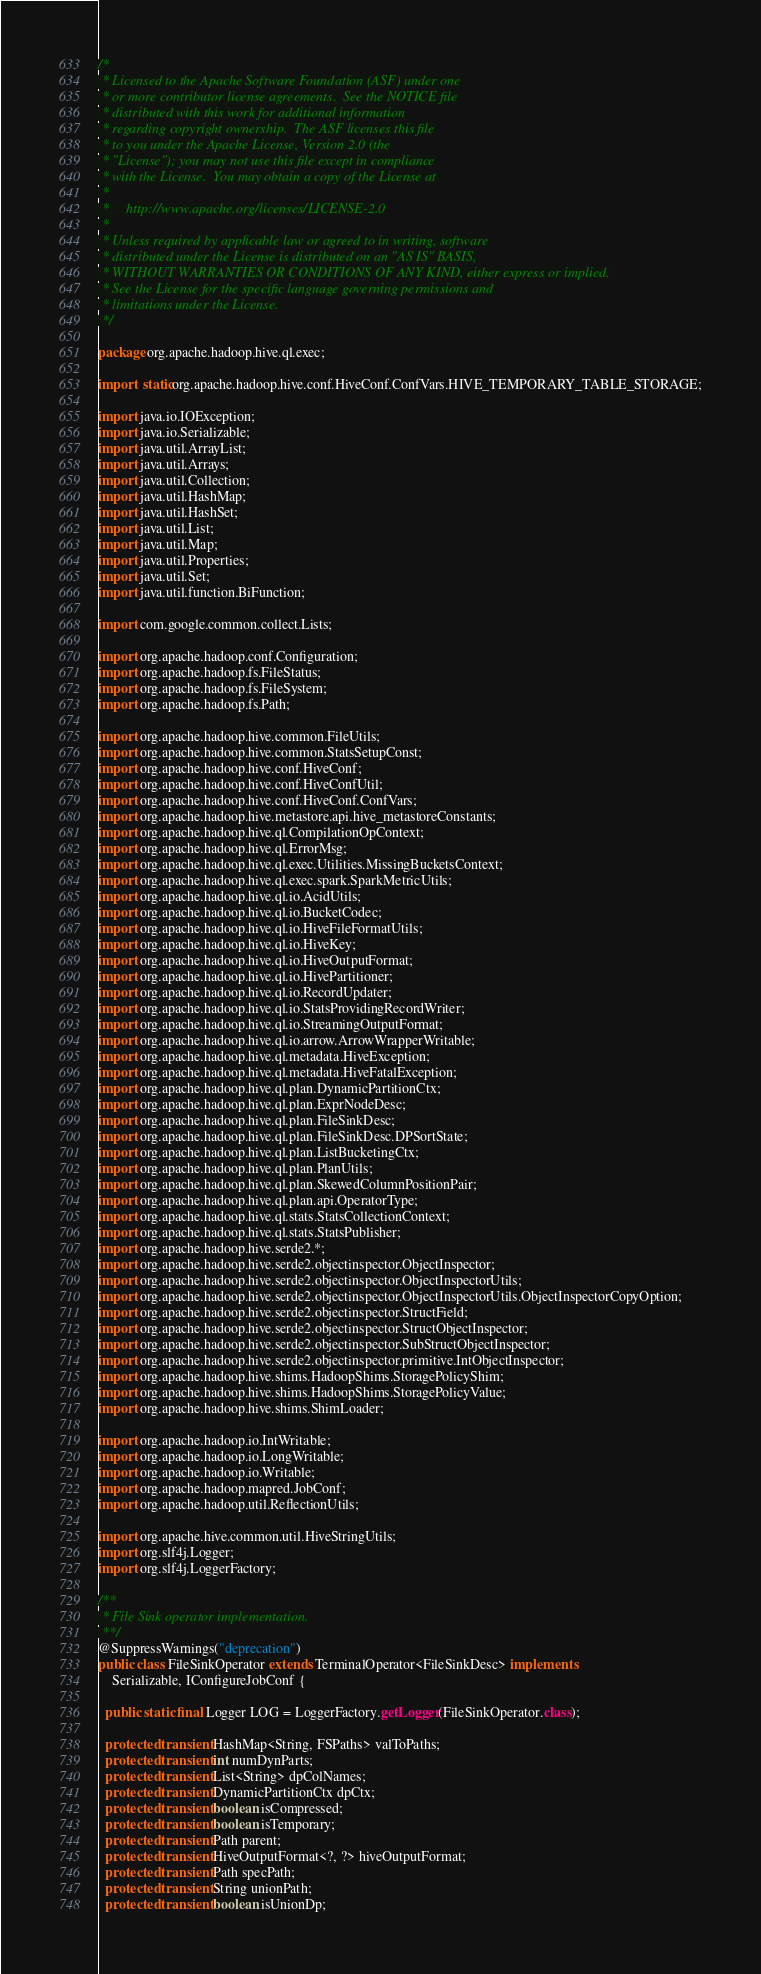Convert code to text. <code><loc_0><loc_0><loc_500><loc_500><_Java_>/*
 * Licensed to the Apache Software Foundation (ASF) under one
 * or more contributor license agreements.  See the NOTICE file
 * distributed with this work for additional information
 * regarding copyright ownership.  The ASF licenses this file
 * to you under the Apache License, Version 2.0 (the
 * "License"); you may not use this file except in compliance
 * with the License.  You may obtain a copy of the License at
 *
 *     http://www.apache.org/licenses/LICENSE-2.0
 *
 * Unless required by applicable law or agreed to in writing, software
 * distributed under the License is distributed on an "AS IS" BASIS,
 * WITHOUT WARRANTIES OR CONDITIONS OF ANY KIND, either express or implied.
 * See the License for the specific language governing permissions and
 * limitations under the License.
 */

package org.apache.hadoop.hive.ql.exec;

import static org.apache.hadoop.hive.conf.HiveConf.ConfVars.HIVE_TEMPORARY_TABLE_STORAGE;

import java.io.IOException;
import java.io.Serializable;
import java.util.ArrayList;
import java.util.Arrays;
import java.util.Collection;
import java.util.HashMap;
import java.util.HashSet;
import java.util.List;
import java.util.Map;
import java.util.Properties;
import java.util.Set;
import java.util.function.BiFunction;

import com.google.common.collect.Lists;

import org.apache.hadoop.conf.Configuration;
import org.apache.hadoop.fs.FileStatus;
import org.apache.hadoop.fs.FileSystem;
import org.apache.hadoop.fs.Path;

import org.apache.hadoop.hive.common.FileUtils;
import org.apache.hadoop.hive.common.StatsSetupConst;
import org.apache.hadoop.hive.conf.HiveConf;
import org.apache.hadoop.hive.conf.HiveConfUtil;
import org.apache.hadoop.hive.conf.HiveConf.ConfVars;
import org.apache.hadoop.hive.metastore.api.hive_metastoreConstants;
import org.apache.hadoop.hive.ql.CompilationOpContext;
import org.apache.hadoop.hive.ql.ErrorMsg;
import org.apache.hadoop.hive.ql.exec.Utilities.MissingBucketsContext;
import org.apache.hadoop.hive.ql.exec.spark.SparkMetricUtils;
import org.apache.hadoop.hive.ql.io.AcidUtils;
import org.apache.hadoop.hive.ql.io.BucketCodec;
import org.apache.hadoop.hive.ql.io.HiveFileFormatUtils;
import org.apache.hadoop.hive.ql.io.HiveKey;
import org.apache.hadoop.hive.ql.io.HiveOutputFormat;
import org.apache.hadoop.hive.ql.io.HivePartitioner;
import org.apache.hadoop.hive.ql.io.RecordUpdater;
import org.apache.hadoop.hive.ql.io.StatsProvidingRecordWriter;
import org.apache.hadoop.hive.ql.io.StreamingOutputFormat;
import org.apache.hadoop.hive.ql.io.arrow.ArrowWrapperWritable;
import org.apache.hadoop.hive.ql.metadata.HiveException;
import org.apache.hadoop.hive.ql.metadata.HiveFatalException;
import org.apache.hadoop.hive.ql.plan.DynamicPartitionCtx;
import org.apache.hadoop.hive.ql.plan.ExprNodeDesc;
import org.apache.hadoop.hive.ql.plan.FileSinkDesc;
import org.apache.hadoop.hive.ql.plan.FileSinkDesc.DPSortState;
import org.apache.hadoop.hive.ql.plan.ListBucketingCtx;
import org.apache.hadoop.hive.ql.plan.PlanUtils;
import org.apache.hadoop.hive.ql.plan.SkewedColumnPositionPair;
import org.apache.hadoop.hive.ql.plan.api.OperatorType;
import org.apache.hadoop.hive.ql.stats.StatsCollectionContext;
import org.apache.hadoop.hive.ql.stats.StatsPublisher;
import org.apache.hadoop.hive.serde2.*;
import org.apache.hadoop.hive.serde2.objectinspector.ObjectInspector;
import org.apache.hadoop.hive.serde2.objectinspector.ObjectInspectorUtils;
import org.apache.hadoop.hive.serde2.objectinspector.ObjectInspectorUtils.ObjectInspectorCopyOption;
import org.apache.hadoop.hive.serde2.objectinspector.StructField;
import org.apache.hadoop.hive.serde2.objectinspector.StructObjectInspector;
import org.apache.hadoop.hive.serde2.objectinspector.SubStructObjectInspector;
import org.apache.hadoop.hive.serde2.objectinspector.primitive.IntObjectInspector;
import org.apache.hadoop.hive.shims.HadoopShims.StoragePolicyShim;
import org.apache.hadoop.hive.shims.HadoopShims.StoragePolicyValue;
import org.apache.hadoop.hive.shims.ShimLoader;

import org.apache.hadoop.io.IntWritable;
import org.apache.hadoop.io.LongWritable;
import org.apache.hadoop.io.Writable;
import org.apache.hadoop.mapred.JobConf;
import org.apache.hadoop.util.ReflectionUtils;

import org.apache.hive.common.util.HiveStringUtils;
import org.slf4j.Logger;
import org.slf4j.LoggerFactory;

/**
 * File Sink operator implementation.
 **/
@SuppressWarnings("deprecation")
public class FileSinkOperator extends TerminalOperator<FileSinkDesc> implements
    Serializable, IConfigureJobConf {

  public static final Logger LOG = LoggerFactory.getLogger(FileSinkOperator.class);

  protected transient HashMap<String, FSPaths> valToPaths;
  protected transient int numDynParts;
  protected transient List<String> dpColNames;
  protected transient DynamicPartitionCtx dpCtx;
  protected transient boolean isCompressed;
  protected transient boolean isTemporary;
  protected transient Path parent;
  protected transient HiveOutputFormat<?, ?> hiveOutputFormat;
  protected transient Path specPath;
  protected transient String unionPath;
  protected transient boolean isUnionDp;</code> 